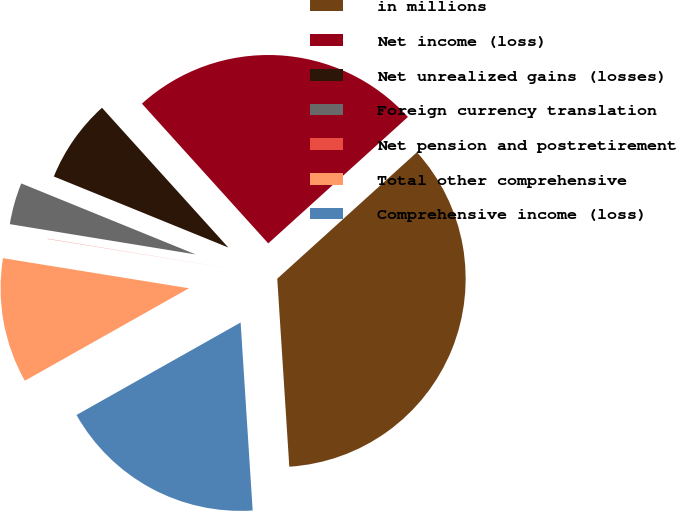Convert chart. <chart><loc_0><loc_0><loc_500><loc_500><pie_chart><fcel>in millions<fcel>Net income (loss)<fcel>Net unrealized gains (losses)<fcel>Foreign currency translation<fcel>Net pension and postretirement<fcel>Total other comprehensive<fcel>Comprehensive income (loss)<nl><fcel>35.69%<fcel>24.99%<fcel>7.15%<fcel>3.58%<fcel>0.02%<fcel>10.72%<fcel>17.85%<nl></chart> 